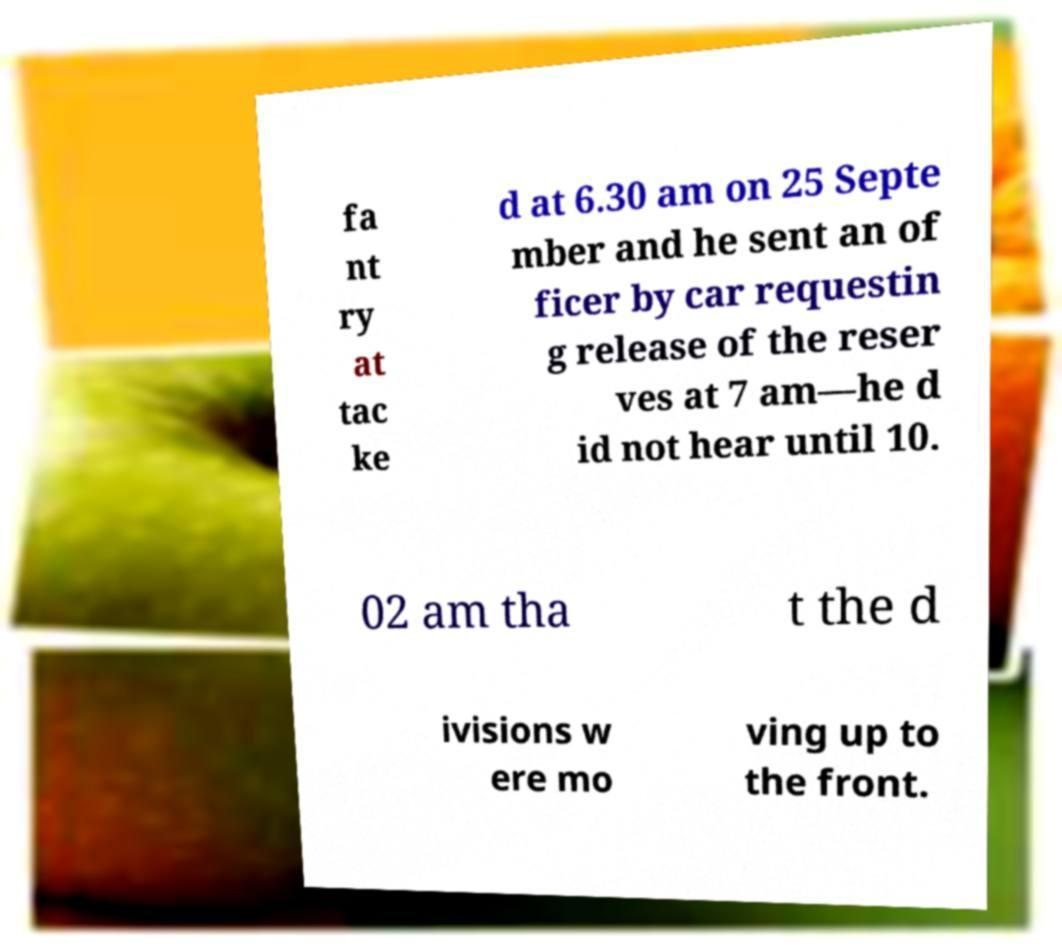I need the written content from this picture converted into text. Can you do that? fa nt ry at tac ke d at 6.30 am on 25 Septe mber and he sent an of ficer by car requestin g release of the reser ves at 7 am—he d id not hear until 10. 02 am tha t the d ivisions w ere mo ving up to the front. 